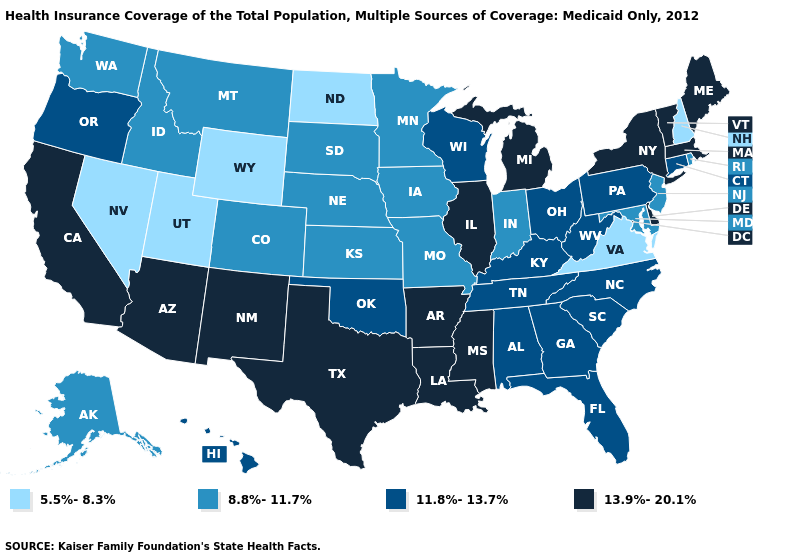Among the states that border Pennsylvania , does West Virginia have the highest value?
Answer briefly. No. What is the value of Oklahoma?
Answer briefly. 11.8%-13.7%. What is the lowest value in the Northeast?
Write a very short answer. 5.5%-8.3%. What is the value of Pennsylvania?
Be succinct. 11.8%-13.7%. How many symbols are there in the legend?
Quick response, please. 4. Among the states that border Illinois , which have the highest value?
Give a very brief answer. Kentucky, Wisconsin. Does Arizona have the highest value in the USA?
Short answer required. Yes. Does Iowa have the highest value in the USA?
Give a very brief answer. No. Is the legend a continuous bar?
Concise answer only. No. Name the states that have a value in the range 13.9%-20.1%?
Give a very brief answer. Arizona, Arkansas, California, Delaware, Illinois, Louisiana, Maine, Massachusetts, Michigan, Mississippi, New Mexico, New York, Texas, Vermont. Does Virginia have the lowest value in the USA?
Quick response, please. Yes. Among the states that border Arkansas , which have the lowest value?
Short answer required. Missouri. Does Wyoming have a lower value than Georgia?
Be succinct. Yes. Does Texas have the same value as Delaware?
Quick response, please. Yes. 